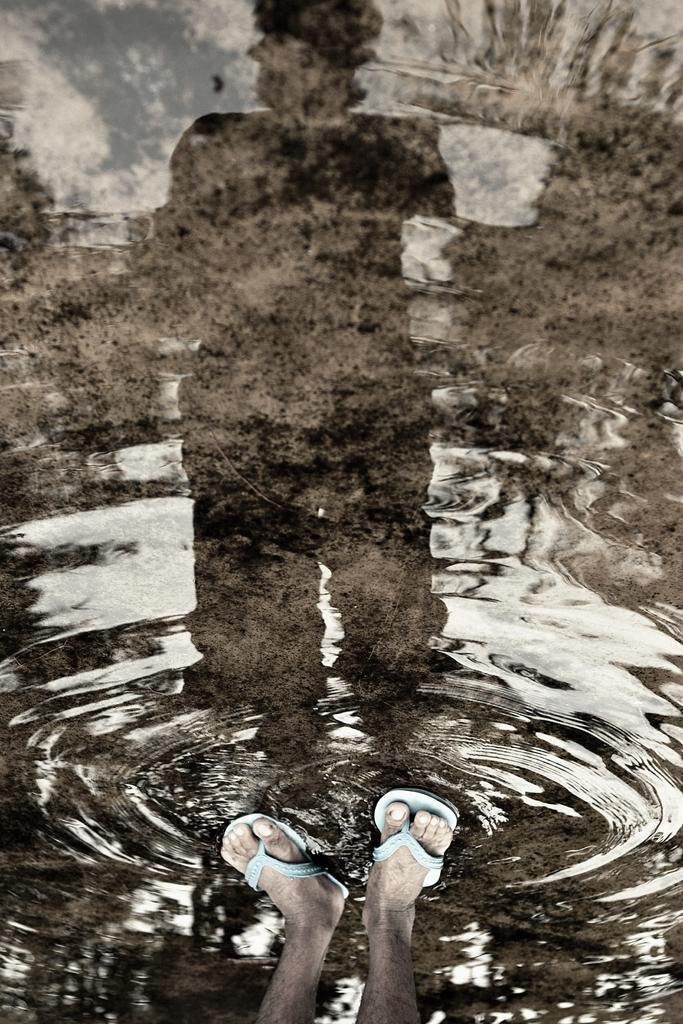In one or two sentences, can you explain what this image depicts? In this picture we can see water and legs of a person, in the water we can see the reflection of a person. 